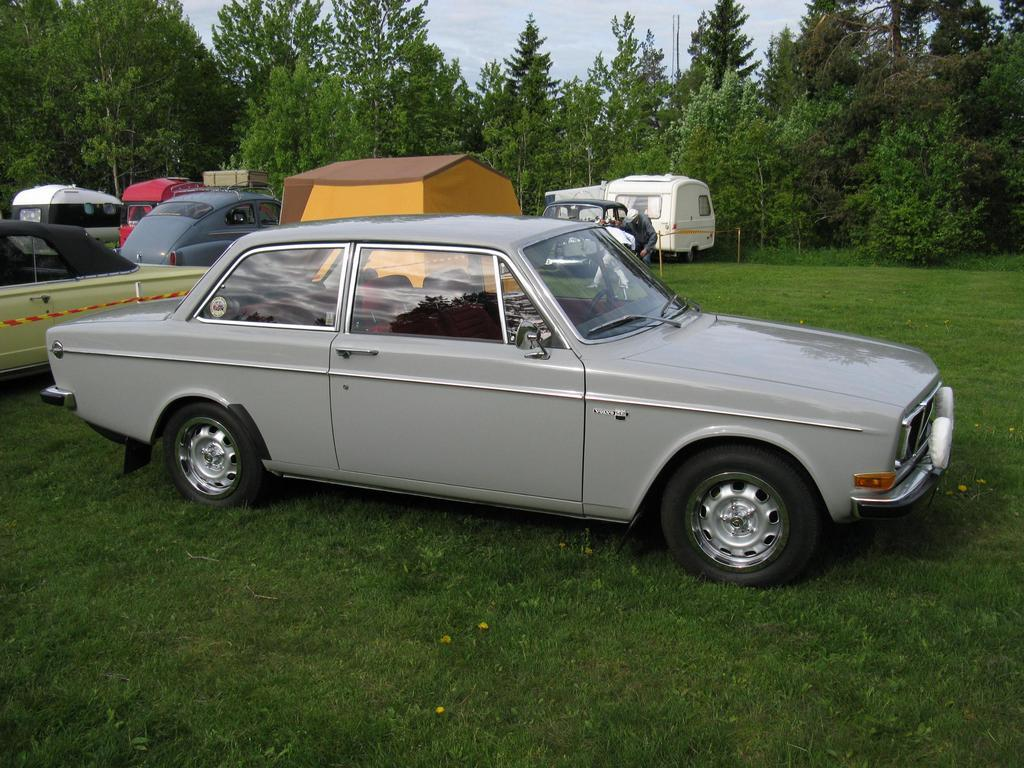What types of objects are present in the image? There are vehicles, a tent, and poles on the ground in the image. Can you describe the person in the image? There is a person in the image. What can be seen in the background of the image? There are trees in the background of the image. What is visible at the top of the image? The sky is visible at the top of the image. What type of punishment is being administered to the trees in the image? There is no punishment being administered to the trees in the image; they are simply visible in the background. Can you describe the curve of the poles in the image? The provided facts do not mention any curves in the poles; they are simply described as being on the ground. 